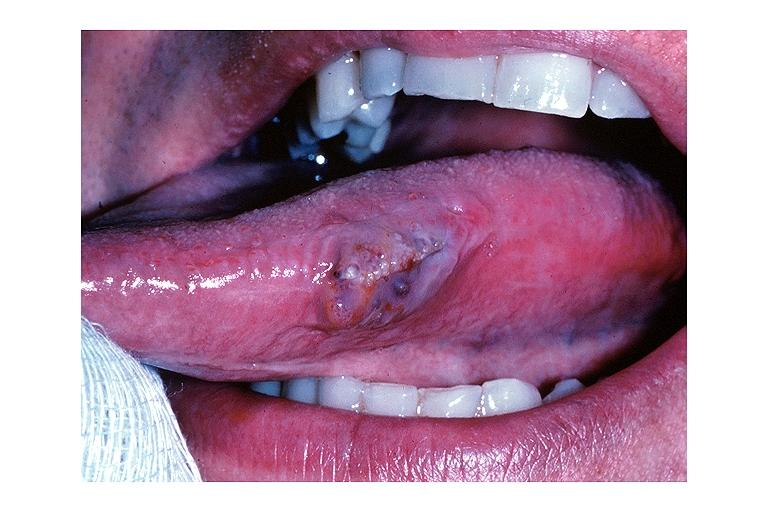s oral present?
Answer the question using a single word or phrase. Yes 